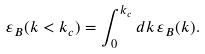Convert formula to latex. <formula><loc_0><loc_0><loc_500><loc_500>\varepsilon _ { B } ( k < k _ { c } ) = \int ^ { k _ { c } } _ { 0 } d k \, \varepsilon _ { B } ( k ) .</formula> 